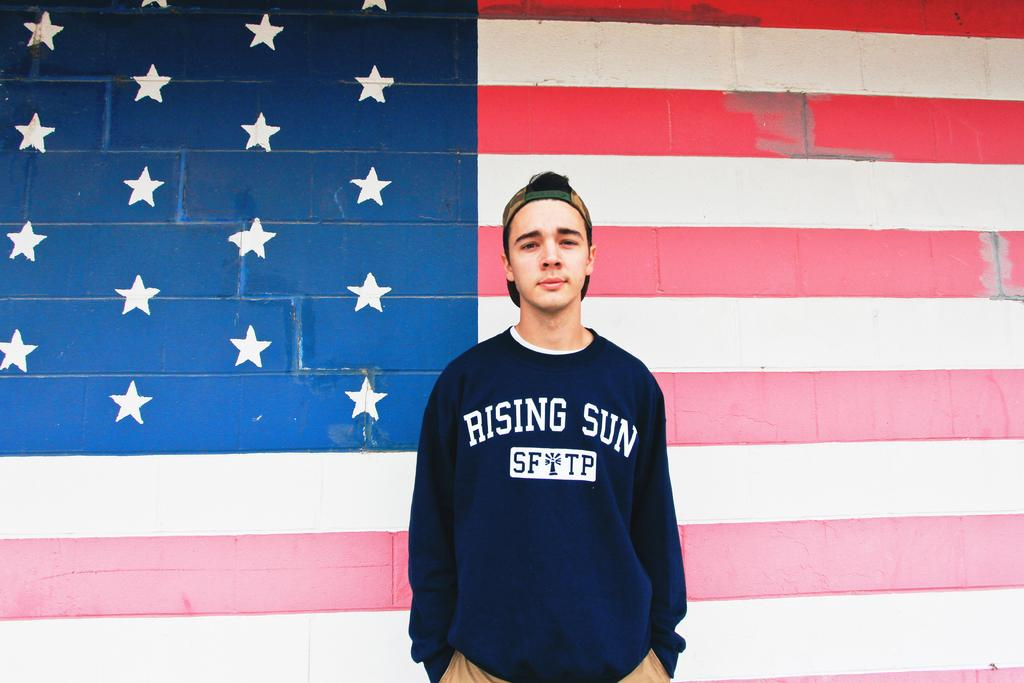Who is present in the image? There is a man in the image. What is the man wearing on his head? The man is wearing a cap. What can be seen on the wall behind the man? There is a painting of a flag on the wall behind the man. What type of plantation can be seen in the image? There is no plantation present in the image. What does the image smell like? The image is a visual representation and does not have a smell. 